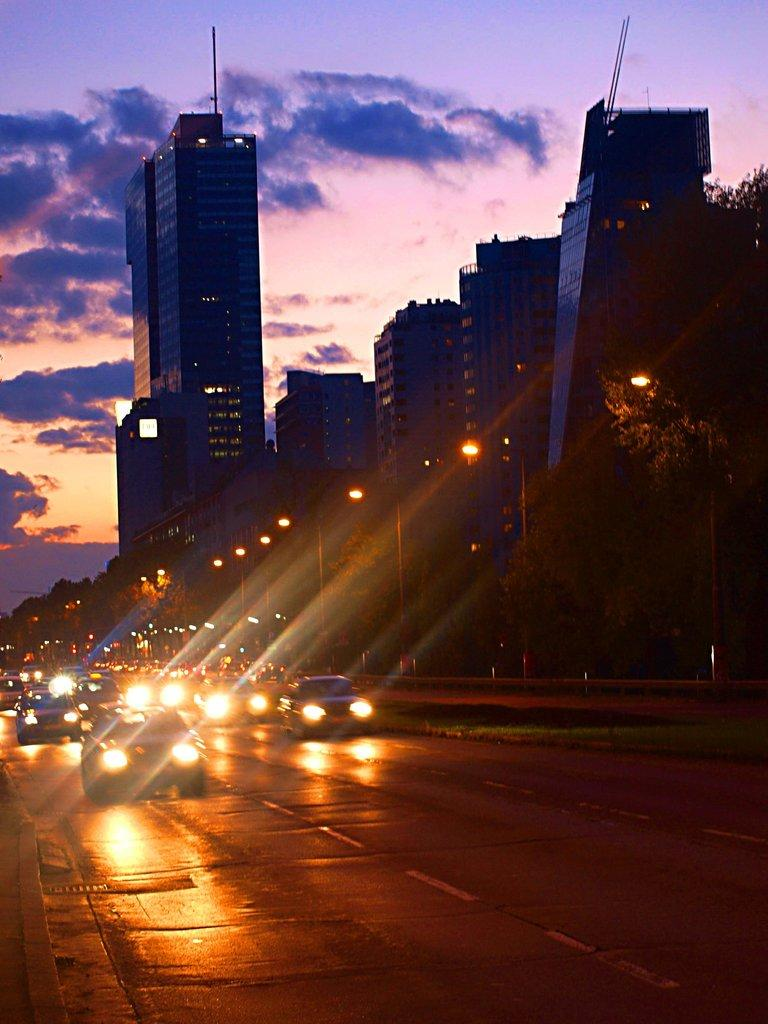What can be seen on the road in the image? There are vehicles on the road in the image. What is located on the right side of the vehicles? There are poles with lights on the right side of the vehicles. What structures are visible behind the vehicles? There are buildings behind the vehicles. What is the condition of the sky in the image? The sky is visible behind the buildings and appears cloudy. How many facts can be found in the image? The term "fact" is not related to the visual content of the image, so it cannot be found in the image. 